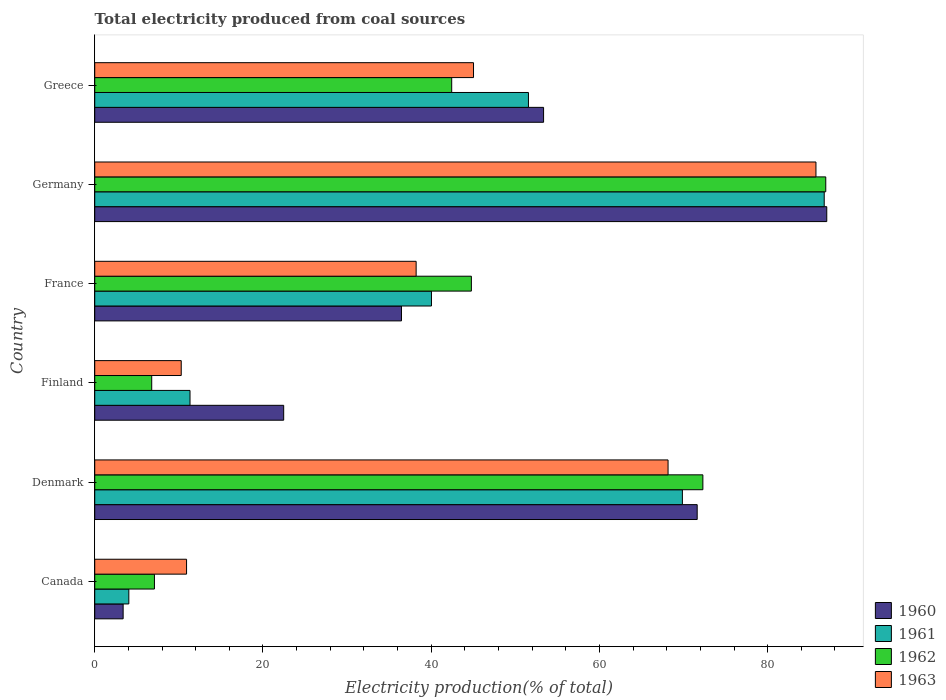How many groups of bars are there?
Provide a short and direct response. 6. Are the number of bars per tick equal to the number of legend labels?
Your response must be concise. Yes. Are the number of bars on each tick of the Y-axis equal?
Ensure brevity in your answer.  Yes. How many bars are there on the 2nd tick from the bottom?
Your response must be concise. 4. In how many cases, is the number of bars for a given country not equal to the number of legend labels?
Make the answer very short. 0. What is the total electricity produced in 1963 in Germany?
Give a very brief answer. 85.74. Across all countries, what is the maximum total electricity produced in 1962?
Ensure brevity in your answer.  86.91. Across all countries, what is the minimum total electricity produced in 1961?
Make the answer very short. 4.05. In which country was the total electricity produced in 1961 maximum?
Provide a short and direct response. Germany. In which country was the total electricity produced in 1960 minimum?
Provide a short and direct response. Canada. What is the total total electricity produced in 1962 in the graph?
Provide a succinct answer. 260.3. What is the difference between the total electricity produced in 1962 in France and that in Greece?
Provide a succinct answer. 2.34. What is the difference between the total electricity produced in 1963 in Greece and the total electricity produced in 1961 in France?
Keep it short and to the point. 5. What is the average total electricity produced in 1963 per country?
Keep it short and to the point. 43.06. What is the difference between the total electricity produced in 1962 and total electricity produced in 1963 in France?
Offer a terse response. 6.57. In how many countries, is the total electricity produced in 1963 greater than 44 %?
Make the answer very short. 3. What is the ratio of the total electricity produced in 1963 in Germany to that in Greece?
Provide a short and direct response. 1.9. What is the difference between the highest and the second highest total electricity produced in 1962?
Keep it short and to the point. 14.61. What is the difference between the highest and the lowest total electricity produced in 1962?
Keep it short and to the point. 80.13. Is it the case that in every country, the sum of the total electricity produced in 1963 and total electricity produced in 1962 is greater than the sum of total electricity produced in 1961 and total electricity produced in 1960?
Give a very brief answer. No. Is it the case that in every country, the sum of the total electricity produced in 1961 and total electricity produced in 1963 is greater than the total electricity produced in 1960?
Offer a terse response. No. How many bars are there?
Your answer should be very brief. 24. What is the difference between two consecutive major ticks on the X-axis?
Offer a very short reply. 20. Does the graph contain any zero values?
Your answer should be compact. No. Does the graph contain grids?
Your response must be concise. No. Where does the legend appear in the graph?
Your answer should be compact. Bottom right. How many legend labels are there?
Your answer should be very brief. 4. What is the title of the graph?
Your answer should be very brief. Total electricity produced from coal sources. Does "1982" appear as one of the legend labels in the graph?
Give a very brief answer. No. What is the label or title of the X-axis?
Ensure brevity in your answer.  Electricity production(% of total). What is the Electricity production(% of total) of 1960 in Canada?
Provide a succinct answer. 3.38. What is the Electricity production(% of total) of 1961 in Canada?
Your answer should be very brief. 4.05. What is the Electricity production(% of total) of 1962 in Canada?
Your answer should be compact. 7.1. What is the Electricity production(% of total) of 1963 in Canada?
Ensure brevity in your answer.  10.92. What is the Electricity production(% of total) in 1960 in Denmark?
Provide a short and direct response. 71.62. What is the Electricity production(% of total) in 1961 in Denmark?
Ensure brevity in your answer.  69.86. What is the Electricity production(% of total) in 1962 in Denmark?
Offer a terse response. 72.3. What is the Electricity production(% of total) in 1963 in Denmark?
Ensure brevity in your answer.  68.16. What is the Electricity production(% of total) in 1960 in Finland?
Your response must be concise. 22.46. What is the Electricity production(% of total) in 1961 in Finland?
Give a very brief answer. 11.33. What is the Electricity production(% of total) of 1962 in Finland?
Your answer should be compact. 6.78. What is the Electricity production(% of total) of 1963 in Finland?
Provide a succinct answer. 10.28. What is the Electricity production(% of total) of 1960 in France?
Make the answer very short. 36.47. What is the Electricity production(% of total) of 1961 in France?
Keep it short and to the point. 40.03. What is the Electricity production(% of total) in 1962 in France?
Provide a short and direct response. 44.78. What is the Electricity production(% of total) of 1963 in France?
Provide a short and direct response. 38.21. What is the Electricity production(% of total) in 1960 in Germany?
Your answer should be very brief. 87.03. What is the Electricity production(% of total) of 1961 in Germany?
Keep it short and to the point. 86.73. What is the Electricity production(% of total) in 1962 in Germany?
Your answer should be very brief. 86.91. What is the Electricity production(% of total) of 1963 in Germany?
Provide a succinct answer. 85.74. What is the Electricity production(% of total) in 1960 in Greece?
Keep it short and to the point. 53.36. What is the Electricity production(% of total) of 1961 in Greece?
Offer a terse response. 51.56. What is the Electricity production(% of total) of 1962 in Greece?
Your response must be concise. 42.44. What is the Electricity production(% of total) of 1963 in Greece?
Give a very brief answer. 45.03. Across all countries, what is the maximum Electricity production(% of total) in 1960?
Your answer should be compact. 87.03. Across all countries, what is the maximum Electricity production(% of total) of 1961?
Your answer should be very brief. 86.73. Across all countries, what is the maximum Electricity production(% of total) in 1962?
Ensure brevity in your answer.  86.91. Across all countries, what is the maximum Electricity production(% of total) in 1963?
Your answer should be very brief. 85.74. Across all countries, what is the minimum Electricity production(% of total) of 1960?
Keep it short and to the point. 3.38. Across all countries, what is the minimum Electricity production(% of total) in 1961?
Provide a succinct answer. 4.05. Across all countries, what is the minimum Electricity production(% of total) in 1962?
Give a very brief answer. 6.78. Across all countries, what is the minimum Electricity production(% of total) in 1963?
Give a very brief answer. 10.28. What is the total Electricity production(% of total) in 1960 in the graph?
Make the answer very short. 274.33. What is the total Electricity production(% of total) of 1961 in the graph?
Your answer should be very brief. 263.57. What is the total Electricity production(% of total) of 1962 in the graph?
Ensure brevity in your answer.  260.3. What is the total Electricity production(% of total) of 1963 in the graph?
Give a very brief answer. 258.35. What is the difference between the Electricity production(% of total) of 1960 in Canada and that in Denmark?
Offer a very short reply. -68.25. What is the difference between the Electricity production(% of total) of 1961 in Canada and that in Denmark?
Your answer should be compact. -65.81. What is the difference between the Electricity production(% of total) of 1962 in Canada and that in Denmark?
Keep it short and to the point. -65.2. What is the difference between the Electricity production(% of total) in 1963 in Canada and that in Denmark?
Provide a succinct answer. -57.24. What is the difference between the Electricity production(% of total) in 1960 in Canada and that in Finland?
Offer a terse response. -19.09. What is the difference between the Electricity production(% of total) of 1961 in Canada and that in Finland?
Keep it short and to the point. -7.27. What is the difference between the Electricity production(% of total) of 1962 in Canada and that in Finland?
Your answer should be compact. 0.32. What is the difference between the Electricity production(% of total) of 1963 in Canada and that in Finland?
Your answer should be very brief. 0.63. What is the difference between the Electricity production(% of total) in 1960 in Canada and that in France?
Provide a succinct answer. -33.09. What is the difference between the Electricity production(% of total) in 1961 in Canada and that in France?
Offer a very short reply. -35.98. What is the difference between the Electricity production(% of total) of 1962 in Canada and that in France?
Give a very brief answer. -37.68. What is the difference between the Electricity production(% of total) of 1963 in Canada and that in France?
Make the answer very short. -27.29. What is the difference between the Electricity production(% of total) of 1960 in Canada and that in Germany?
Provide a succinct answer. -83.65. What is the difference between the Electricity production(% of total) of 1961 in Canada and that in Germany?
Your answer should be very brief. -82.67. What is the difference between the Electricity production(% of total) of 1962 in Canada and that in Germany?
Your answer should be compact. -79.81. What is the difference between the Electricity production(% of total) in 1963 in Canada and that in Germany?
Make the answer very short. -74.83. What is the difference between the Electricity production(% of total) of 1960 in Canada and that in Greece?
Ensure brevity in your answer.  -49.98. What is the difference between the Electricity production(% of total) in 1961 in Canada and that in Greece?
Provide a short and direct response. -47.51. What is the difference between the Electricity production(% of total) of 1962 in Canada and that in Greece?
Keep it short and to the point. -35.34. What is the difference between the Electricity production(% of total) in 1963 in Canada and that in Greece?
Ensure brevity in your answer.  -34.11. What is the difference between the Electricity production(% of total) in 1960 in Denmark and that in Finland?
Offer a very short reply. 49.16. What is the difference between the Electricity production(% of total) of 1961 in Denmark and that in Finland?
Provide a short and direct response. 58.54. What is the difference between the Electricity production(% of total) in 1962 in Denmark and that in Finland?
Provide a succinct answer. 65.53. What is the difference between the Electricity production(% of total) of 1963 in Denmark and that in Finland?
Ensure brevity in your answer.  57.88. What is the difference between the Electricity production(% of total) of 1960 in Denmark and that in France?
Your answer should be compact. 35.16. What is the difference between the Electricity production(% of total) in 1961 in Denmark and that in France?
Your answer should be very brief. 29.83. What is the difference between the Electricity production(% of total) of 1962 in Denmark and that in France?
Your answer should be compact. 27.52. What is the difference between the Electricity production(% of total) of 1963 in Denmark and that in France?
Provide a succinct answer. 29.95. What is the difference between the Electricity production(% of total) of 1960 in Denmark and that in Germany?
Provide a succinct answer. -15.4. What is the difference between the Electricity production(% of total) in 1961 in Denmark and that in Germany?
Offer a terse response. -16.86. What is the difference between the Electricity production(% of total) of 1962 in Denmark and that in Germany?
Offer a very short reply. -14.61. What is the difference between the Electricity production(% of total) of 1963 in Denmark and that in Germany?
Your answer should be very brief. -17.58. What is the difference between the Electricity production(% of total) in 1960 in Denmark and that in Greece?
Ensure brevity in your answer.  18.26. What is the difference between the Electricity production(% of total) of 1961 in Denmark and that in Greece?
Your response must be concise. 18.3. What is the difference between the Electricity production(% of total) of 1962 in Denmark and that in Greece?
Provide a succinct answer. 29.86. What is the difference between the Electricity production(% of total) in 1963 in Denmark and that in Greece?
Provide a short and direct response. 23.13. What is the difference between the Electricity production(% of total) of 1960 in Finland and that in France?
Your answer should be very brief. -14.01. What is the difference between the Electricity production(% of total) of 1961 in Finland and that in France?
Your answer should be compact. -28.71. What is the difference between the Electricity production(% of total) in 1962 in Finland and that in France?
Keep it short and to the point. -38. What is the difference between the Electricity production(% of total) in 1963 in Finland and that in France?
Your answer should be compact. -27.93. What is the difference between the Electricity production(% of total) of 1960 in Finland and that in Germany?
Keep it short and to the point. -64.57. What is the difference between the Electricity production(% of total) of 1961 in Finland and that in Germany?
Your response must be concise. -75.4. What is the difference between the Electricity production(% of total) of 1962 in Finland and that in Germany?
Your answer should be compact. -80.13. What is the difference between the Electricity production(% of total) in 1963 in Finland and that in Germany?
Give a very brief answer. -75.46. What is the difference between the Electricity production(% of total) of 1960 in Finland and that in Greece?
Provide a short and direct response. -30.9. What is the difference between the Electricity production(% of total) in 1961 in Finland and that in Greece?
Ensure brevity in your answer.  -40.24. What is the difference between the Electricity production(% of total) in 1962 in Finland and that in Greece?
Provide a short and direct response. -35.66. What is the difference between the Electricity production(% of total) of 1963 in Finland and that in Greece?
Provide a succinct answer. -34.75. What is the difference between the Electricity production(% of total) in 1960 in France and that in Germany?
Provide a short and direct response. -50.56. What is the difference between the Electricity production(% of total) in 1961 in France and that in Germany?
Offer a terse response. -46.69. What is the difference between the Electricity production(% of total) of 1962 in France and that in Germany?
Keep it short and to the point. -42.13. What is the difference between the Electricity production(% of total) in 1963 in France and that in Germany?
Keep it short and to the point. -47.53. What is the difference between the Electricity production(% of total) of 1960 in France and that in Greece?
Your response must be concise. -16.89. What is the difference between the Electricity production(% of total) in 1961 in France and that in Greece?
Offer a terse response. -11.53. What is the difference between the Electricity production(% of total) of 1962 in France and that in Greece?
Make the answer very short. 2.34. What is the difference between the Electricity production(% of total) of 1963 in France and that in Greece?
Your response must be concise. -6.82. What is the difference between the Electricity production(% of total) in 1960 in Germany and that in Greece?
Keep it short and to the point. 33.67. What is the difference between the Electricity production(% of total) of 1961 in Germany and that in Greece?
Your response must be concise. 35.16. What is the difference between the Electricity production(% of total) of 1962 in Germany and that in Greece?
Provide a succinct answer. 44.47. What is the difference between the Electricity production(% of total) of 1963 in Germany and that in Greece?
Your response must be concise. 40.71. What is the difference between the Electricity production(% of total) of 1960 in Canada and the Electricity production(% of total) of 1961 in Denmark?
Offer a very short reply. -66.49. What is the difference between the Electricity production(% of total) in 1960 in Canada and the Electricity production(% of total) in 1962 in Denmark?
Your answer should be compact. -68.92. What is the difference between the Electricity production(% of total) of 1960 in Canada and the Electricity production(% of total) of 1963 in Denmark?
Keep it short and to the point. -64.78. What is the difference between the Electricity production(% of total) in 1961 in Canada and the Electricity production(% of total) in 1962 in Denmark?
Ensure brevity in your answer.  -68.25. What is the difference between the Electricity production(% of total) of 1961 in Canada and the Electricity production(% of total) of 1963 in Denmark?
Provide a succinct answer. -64.11. What is the difference between the Electricity production(% of total) in 1962 in Canada and the Electricity production(% of total) in 1963 in Denmark?
Ensure brevity in your answer.  -61.06. What is the difference between the Electricity production(% of total) in 1960 in Canada and the Electricity production(% of total) in 1961 in Finland?
Keep it short and to the point. -7.95. What is the difference between the Electricity production(% of total) of 1960 in Canada and the Electricity production(% of total) of 1962 in Finland?
Offer a terse response. -3.4. What is the difference between the Electricity production(% of total) in 1960 in Canada and the Electricity production(% of total) in 1963 in Finland?
Give a very brief answer. -6.91. What is the difference between the Electricity production(% of total) in 1961 in Canada and the Electricity production(% of total) in 1962 in Finland?
Keep it short and to the point. -2.72. What is the difference between the Electricity production(% of total) of 1961 in Canada and the Electricity production(% of total) of 1963 in Finland?
Give a very brief answer. -6.23. What is the difference between the Electricity production(% of total) in 1962 in Canada and the Electricity production(% of total) in 1963 in Finland?
Ensure brevity in your answer.  -3.18. What is the difference between the Electricity production(% of total) of 1960 in Canada and the Electricity production(% of total) of 1961 in France?
Provide a short and direct response. -36.66. What is the difference between the Electricity production(% of total) in 1960 in Canada and the Electricity production(% of total) in 1962 in France?
Offer a very short reply. -41.4. What is the difference between the Electricity production(% of total) in 1960 in Canada and the Electricity production(% of total) in 1963 in France?
Make the answer very short. -34.83. What is the difference between the Electricity production(% of total) of 1961 in Canada and the Electricity production(% of total) of 1962 in France?
Offer a very short reply. -40.72. What is the difference between the Electricity production(% of total) of 1961 in Canada and the Electricity production(% of total) of 1963 in France?
Ensure brevity in your answer.  -34.16. What is the difference between the Electricity production(% of total) in 1962 in Canada and the Electricity production(% of total) in 1963 in France?
Ensure brevity in your answer.  -31.11. What is the difference between the Electricity production(% of total) in 1960 in Canada and the Electricity production(% of total) in 1961 in Germany?
Provide a short and direct response. -83.35. What is the difference between the Electricity production(% of total) in 1960 in Canada and the Electricity production(% of total) in 1962 in Germany?
Your answer should be very brief. -83.53. What is the difference between the Electricity production(% of total) in 1960 in Canada and the Electricity production(% of total) in 1963 in Germany?
Your answer should be compact. -82.36. What is the difference between the Electricity production(% of total) in 1961 in Canada and the Electricity production(% of total) in 1962 in Germany?
Give a very brief answer. -82.86. What is the difference between the Electricity production(% of total) of 1961 in Canada and the Electricity production(% of total) of 1963 in Germany?
Your answer should be compact. -81.69. What is the difference between the Electricity production(% of total) in 1962 in Canada and the Electricity production(% of total) in 1963 in Germany?
Make the answer very short. -78.64. What is the difference between the Electricity production(% of total) in 1960 in Canada and the Electricity production(% of total) in 1961 in Greece?
Give a very brief answer. -48.19. What is the difference between the Electricity production(% of total) of 1960 in Canada and the Electricity production(% of total) of 1962 in Greece?
Keep it short and to the point. -39.06. What is the difference between the Electricity production(% of total) in 1960 in Canada and the Electricity production(% of total) in 1963 in Greece?
Offer a terse response. -41.65. What is the difference between the Electricity production(% of total) in 1961 in Canada and the Electricity production(% of total) in 1962 in Greece?
Give a very brief answer. -38.39. What is the difference between the Electricity production(% of total) of 1961 in Canada and the Electricity production(% of total) of 1963 in Greece?
Keep it short and to the point. -40.98. What is the difference between the Electricity production(% of total) in 1962 in Canada and the Electricity production(% of total) in 1963 in Greece?
Make the answer very short. -37.93. What is the difference between the Electricity production(% of total) of 1960 in Denmark and the Electricity production(% of total) of 1961 in Finland?
Provide a short and direct response. 60.3. What is the difference between the Electricity production(% of total) of 1960 in Denmark and the Electricity production(% of total) of 1962 in Finland?
Your answer should be compact. 64.85. What is the difference between the Electricity production(% of total) in 1960 in Denmark and the Electricity production(% of total) in 1963 in Finland?
Keep it short and to the point. 61.34. What is the difference between the Electricity production(% of total) in 1961 in Denmark and the Electricity production(% of total) in 1962 in Finland?
Provide a succinct answer. 63.09. What is the difference between the Electricity production(% of total) of 1961 in Denmark and the Electricity production(% of total) of 1963 in Finland?
Make the answer very short. 59.58. What is the difference between the Electricity production(% of total) of 1962 in Denmark and the Electricity production(% of total) of 1963 in Finland?
Your answer should be compact. 62.02. What is the difference between the Electricity production(% of total) of 1960 in Denmark and the Electricity production(% of total) of 1961 in France?
Keep it short and to the point. 31.59. What is the difference between the Electricity production(% of total) of 1960 in Denmark and the Electricity production(% of total) of 1962 in France?
Offer a very short reply. 26.85. What is the difference between the Electricity production(% of total) of 1960 in Denmark and the Electricity production(% of total) of 1963 in France?
Offer a terse response. 33.41. What is the difference between the Electricity production(% of total) of 1961 in Denmark and the Electricity production(% of total) of 1962 in France?
Your answer should be compact. 25.09. What is the difference between the Electricity production(% of total) in 1961 in Denmark and the Electricity production(% of total) in 1963 in France?
Your answer should be compact. 31.65. What is the difference between the Electricity production(% of total) in 1962 in Denmark and the Electricity production(% of total) in 1963 in France?
Provide a succinct answer. 34.09. What is the difference between the Electricity production(% of total) in 1960 in Denmark and the Electricity production(% of total) in 1961 in Germany?
Your response must be concise. -15.1. What is the difference between the Electricity production(% of total) of 1960 in Denmark and the Electricity production(% of total) of 1962 in Germany?
Keep it short and to the point. -15.28. What is the difference between the Electricity production(% of total) of 1960 in Denmark and the Electricity production(% of total) of 1963 in Germany?
Your answer should be compact. -14.12. What is the difference between the Electricity production(% of total) in 1961 in Denmark and the Electricity production(% of total) in 1962 in Germany?
Offer a very short reply. -17.04. What is the difference between the Electricity production(% of total) in 1961 in Denmark and the Electricity production(% of total) in 1963 in Germany?
Keep it short and to the point. -15.88. What is the difference between the Electricity production(% of total) in 1962 in Denmark and the Electricity production(% of total) in 1963 in Germany?
Ensure brevity in your answer.  -13.44. What is the difference between the Electricity production(% of total) of 1960 in Denmark and the Electricity production(% of total) of 1961 in Greece?
Offer a very short reply. 20.06. What is the difference between the Electricity production(% of total) in 1960 in Denmark and the Electricity production(% of total) in 1962 in Greece?
Provide a succinct answer. 29.18. What is the difference between the Electricity production(% of total) in 1960 in Denmark and the Electricity production(% of total) in 1963 in Greece?
Ensure brevity in your answer.  26.59. What is the difference between the Electricity production(% of total) in 1961 in Denmark and the Electricity production(% of total) in 1962 in Greece?
Ensure brevity in your answer.  27.42. What is the difference between the Electricity production(% of total) of 1961 in Denmark and the Electricity production(% of total) of 1963 in Greece?
Make the answer very short. 24.83. What is the difference between the Electricity production(% of total) of 1962 in Denmark and the Electricity production(% of total) of 1963 in Greece?
Your answer should be compact. 27.27. What is the difference between the Electricity production(% of total) in 1960 in Finland and the Electricity production(% of total) in 1961 in France?
Ensure brevity in your answer.  -17.57. What is the difference between the Electricity production(% of total) of 1960 in Finland and the Electricity production(% of total) of 1962 in France?
Provide a short and direct response. -22.31. What is the difference between the Electricity production(% of total) in 1960 in Finland and the Electricity production(% of total) in 1963 in France?
Provide a succinct answer. -15.75. What is the difference between the Electricity production(% of total) of 1961 in Finland and the Electricity production(% of total) of 1962 in France?
Offer a terse response. -33.45. What is the difference between the Electricity production(% of total) in 1961 in Finland and the Electricity production(% of total) in 1963 in France?
Offer a very short reply. -26.88. What is the difference between the Electricity production(% of total) of 1962 in Finland and the Electricity production(% of total) of 1963 in France?
Provide a succinct answer. -31.44. What is the difference between the Electricity production(% of total) in 1960 in Finland and the Electricity production(% of total) in 1961 in Germany?
Offer a very short reply. -64.26. What is the difference between the Electricity production(% of total) in 1960 in Finland and the Electricity production(% of total) in 1962 in Germany?
Your answer should be compact. -64.45. What is the difference between the Electricity production(% of total) in 1960 in Finland and the Electricity production(% of total) in 1963 in Germany?
Your answer should be very brief. -63.28. What is the difference between the Electricity production(% of total) of 1961 in Finland and the Electricity production(% of total) of 1962 in Germany?
Keep it short and to the point. -75.58. What is the difference between the Electricity production(% of total) of 1961 in Finland and the Electricity production(% of total) of 1963 in Germany?
Provide a short and direct response. -74.41. What is the difference between the Electricity production(% of total) in 1962 in Finland and the Electricity production(% of total) in 1963 in Germany?
Your response must be concise. -78.97. What is the difference between the Electricity production(% of total) in 1960 in Finland and the Electricity production(% of total) in 1961 in Greece?
Your response must be concise. -29.1. What is the difference between the Electricity production(% of total) in 1960 in Finland and the Electricity production(% of total) in 1962 in Greece?
Make the answer very short. -19.98. What is the difference between the Electricity production(% of total) of 1960 in Finland and the Electricity production(% of total) of 1963 in Greece?
Your answer should be compact. -22.57. What is the difference between the Electricity production(% of total) in 1961 in Finland and the Electricity production(% of total) in 1962 in Greece?
Offer a terse response. -31.11. What is the difference between the Electricity production(% of total) of 1961 in Finland and the Electricity production(% of total) of 1963 in Greece?
Make the answer very short. -33.7. What is the difference between the Electricity production(% of total) of 1962 in Finland and the Electricity production(% of total) of 1963 in Greece?
Keep it short and to the point. -38.26. What is the difference between the Electricity production(% of total) of 1960 in France and the Electricity production(% of total) of 1961 in Germany?
Your answer should be very brief. -50.26. What is the difference between the Electricity production(% of total) of 1960 in France and the Electricity production(% of total) of 1962 in Germany?
Provide a succinct answer. -50.44. What is the difference between the Electricity production(% of total) of 1960 in France and the Electricity production(% of total) of 1963 in Germany?
Keep it short and to the point. -49.27. What is the difference between the Electricity production(% of total) in 1961 in France and the Electricity production(% of total) in 1962 in Germany?
Ensure brevity in your answer.  -46.87. What is the difference between the Electricity production(% of total) of 1961 in France and the Electricity production(% of total) of 1963 in Germany?
Your response must be concise. -45.71. What is the difference between the Electricity production(% of total) of 1962 in France and the Electricity production(% of total) of 1963 in Germany?
Your answer should be compact. -40.97. What is the difference between the Electricity production(% of total) of 1960 in France and the Electricity production(% of total) of 1961 in Greece?
Provide a succinct answer. -15.09. What is the difference between the Electricity production(% of total) of 1960 in France and the Electricity production(% of total) of 1962 in Greece?
Offer a terse response. -5.97. What is the difference between the Electricity production(% of total) of 1960 in France and the Electricity production(% of total) of 1963 in Greece?
Give a very brief answer. -8.56. What is the difference between the Electricity production(% of total) of 1961 in France and the Electricity production(% of total) of 1962 in Greece?
Provide a succinct answer. -2.41. What is the difference between the Electricity production(% of total) in 1961 in France and the Electricity production(% of total) in 1963 in Greece?
Provide a short and direct response. -5. What is the difference between the Electricity production(% of total) in 1962 in France and the Electricity production(% of total) in 1963 in Greece?
Provide a succinct answer. -0.25. What is the difference between the Electricity production(% of total) in 1960 in Germany and the Electricity production(% of total) in 1961 in Greece?
Your response must be concise. 35.47. What is the difference between the Electricity production(% of total) of 1960 in Germany and the Electricity production(% of total) of 1962 in Greece?
Give a very brief answer. 44.59. What is the difference between the Electricity production(% of total) of 1960 in Germany and the Electricity production(% of total) of 1963 in Greece?
Offer a terse response. 42. What is the difference between the Electricity production(% of total) of 1961 in Germany and the Electricity production(% of total) of 1962 in Greece?
Provide a short and direct response. 44.29. What is the difference between the Electricity production(% of total) of 1961 in Germany and the Electricity production(% of total) of 1963 in Greece?
Your response must be concise. 41.69. What is the difference between the Electricity production(% of total) of 1962 in Germany and the Electricity production(% of total) of 1963 in Greece?
Offer a terse response. 41.88. What is the average Electricity production(% of total) in 1960 per country?
Offer a very short reply. 45.72. What is the average Electricity production(% of total) of 1961 per country?
Your response must be concise. 43.93. What is the average Electricity production(% of total) in 1962 per country?
Offer a terse response. 43.38. What is the average Electricity production(% of total) of 1963 per country?
Offer a terse response. 43.06. What is the difference between the Electricity production(% of total) in 1960 and Electricity production(% of total) in 1961 in Canada?
Provide a succinct answer. -0.68. What is the difference between the Electricity production(% of total) in 1960 and Electricity production(% of total) in 1962 in Canada?
Keep it short and to the point. -3.72. What is the difference between the Electricity production(% of total) of 1960 and Electricity production(% of total) of 1963 in Canada?
Offer a very short reply. -7.54. What is the difference between the Electricity production(% of total) in 1961 and Electricity production(% of total) in 1962 in Canada?
Keep it short and to the point. -3.04. What is the difference between the Electricity production(% of total) in 1961 and Electricity production(% of total) in 1963 in Canada?
Provide a short and direct response. -6.86. What is the difference between the Electricity production(% of total) in 1962 and Electricity production(% of total) in 1963 in Canada?
Your response must be concise. -3.82. What is the difference between the Electricity production(% of total) of 1960 and Electricity production(% of total) of 1961 in Denmark?
Your answer should be compact. 1.76. What is the difference between the Electricity production(% of total) of 1960 and Electricity production(% of total) of 1962 in Denmark?
Keep it short and to the point. -0.68. What is the difference between the Electricity production(% of total) in 1960 and Electricity production(% of total) in 1963 in Denmark?
Your answer should be very brief. 3.46. What is the difference between the Electricity production(% of total) in 1961 and Electricity production(% of total) in 1962 in Denmark?
Ensure brevity in your answer.  -2.44. What is the difference between the Electricity production(% of total) in 1961 and Electricity production(% of total) in 1963 in Denmark?
Your answer should be compact. 1.7. What is the difference between the Electricity production(% of total) of 1962 and Electricity production(% of total) of 1963 in Denmark?
Make the answer very short. 4.14. What is the difference between the Electricity production(% of total) in 1960 and Electricity production(% of total) in 1961 in Finland?
Provide a short and direct response. 11.14. What is the difference between the Electricity production(% of total) of 1960 and Electricity production(% of total) of 1962 in Finland?
Keep it short and to the point. 15.69. What is the difference between the Electricity production(% of total) of 1960 and Electricity production(% of total) of 1963 in Finland?
Your answer should be compact. 12.18. What is the difference between the Electricity production(% of total) in 1961 and Electricity production(% of total) in 1962 in Finland?
Offer a very short reply. 4.55. What is the difference between the Electricity production(% of total) of 1961 and Electricity production(% of total) of 1963 in Finland?
Your response must be concise. 1.04. What is the difference between the Electricity production(% of total) of 1962 and Electricity production(% of total) of 1963 in Finland?
Provide a short and direct response. -3.51. What is the difference between the Electricity production(% of total) in 1960 and Electricity production(% of total) in 1961 in France?
Provide a short and direct response. -3.57. What is the difference between the Electricity production(% of total) of 1960 and Electricity production(% of total) of 1962 in France?
Your answer should be very brief. -8.31. What is the difference between the Electricity production(% of total) in 1960 and Electricity production(% of total) in 1963 in France?
Keep it short and to the point. -1.74. What is the difference between the Electricity production(% of total) of 1961 and Electricity production(% of total) of 1962 in France?
Provide a succinct answer. -4.74. What is the difference between the Electricity production(% of total) of 1961 and Electricity production(% of total) of 1963 in France?
Ensure brevity in your answer.  1.82. What is the difference between the Electricity production(% of total) in 1962 and Electricity production(% of total) in 1963 in France?
Ensure brevity in your answer.  6.57. What is the difference between the Electricity production(% of total) of 1960 and Electricity production(% of total) of 1961 in Germany?
Keep it short and to the point. 0.3. What is the difference between the Electricity production(% of total) in 1960 and Electricity production(% of total) in 1962 in Germany?
Offer a terse response. 0.12. What is the difference between the Electricity production(% of total) of 1960 and Electricity production(% of total) of 1963 in Germany?
Your answer should be very brief. 1.29. What is the difference between the Electricity production(% of total) in 1961 and Electricity production(% of total) in 1962 in Germany?
Provide a succinct answer. -0.18. What is the difference between the Electricity production(% of total) in 1961 and Electricity production(% of total) in 1963 in Germany?
Provide a short and direct response. 0.98. What is the difference between the Electricity production(% of total) of 1962 and Electricity production(% of total) of 1963 in Germany?
Ensure brevity in your answer.  1.17. What is the difference between the Electricity production(% of total) of 1960 and Electricity production(% of total) of 1961 in Greece?
Your answer should be compact. 1.8. What is the difference between the Electricity production(% of total) of 1960 and Electricity production(% of total) of 1962 in Greece?
Your response must be concise. 10.92. What is the difference between the Electricity production(% of total) of 1960 and Electricity production(% of total) of 1963 in Greece?
Keep it short and to the point. 8.33. What is the difference between the Electricity production(% of total) in 1961 and Electricity production(% of total) in 1962 in Greece?
Make the answer very short. 9.12. What is the difference between the Electricity production(% of total) of 1961 and Electricity production(% of total) of 1963 in Greece?
Offer a terse response. 6.53. What is the difference between the Electricity production(% of total) in 1962 and Electricity production(% of total) in 1963 in Greece?
Provide a succinct answer. -2.59. What is the ratio of the Electricity production(% of total) in 1960 in Canada to that in Denmark?
Keep it short and to the point. 0.05. What is the ratio of the Electricity production(% of total) of 1961 in Canada to that in Denmark?
Your response must be concise. 0.06. What is the ratio of the Electricity production(% of total) in 1962 in Canada to that in Denmark?
Give a very brief answer. 0.1. What is the ratio of the Electricity production(% of total) in 1963 in Canada to that in Denmark?
Your answer should be very brief. 0.16. What is the ratio of the Electricity production(% of total) of 1960 in Canada to that in Finland?
Your response must be concise. 0.15. What is the ratio of the Electricity production(% of total) in 1961 in Canada to that in Finland?
Offer a terse response. 0.36. What is the ratio of the Electricity production(% of total) of 1962 in Canada to that in Finland?
Ensure brevity in your answer.  1.05. What is the ratio of the Electricity production(% of total) in 1963 in Canada to that in Finland?
Offer a very short reply. 1.06. What is the ratio of the Electricity production(% of total) in 1960 in Canada to that in France?
Your answer should be compact. 0.09. What is the ratio of the Electricity production(% of total) of 1961 in Canada to that in France?
Provide a succinct answer. 0.1. What is the ratio of the Electricity production(% of total) in 1962 in Canada to that in France?
Your answer should be very brief. 0.16. What is the ratio of the Electricity production(% of total) in 1963 in Canada to that in France?
Keep it short and to the point. 0.29. What is the ratio of the Electricity production(% of total) in 1960 in Canada to that in Germany?
Offer a terse response. 0.04. What is the ratio of the Electricity production(% of total) in 1961 in Canada to that in Germany?
Offer a terse response. 0.05. What is the ratio of the Electricity production(% of total) of 1962 in Canada to that in Germany?
Your answer should be compact. 0.08. What is the ratio of the Electricity production(% of total) of 1963 in Canada to that in Germany?
Offer a terse response. 0.13. What is the ratio of the Electricity production(% of total) in 1960 in Canada to that in Greece?
Make the answer very short. 0.06. What is the ratio of the Electricity production(% of total) in 1961 in Canada to that in Greece?
Provide a succinct answer. 0.08. What is the ratio of the Electricity production(% of total) of 1962 in Canada to that in Greece?
Provide a short and direct response. 0.17. What is the ratio of the Electricity production(% of total) in 1963 in Canada to that in Greece?
Your answer should be very brief. 0.24. What is the ratio of the Electricity production(% of total) in 1960 in Denmark to that in Finland?
Provide a succinct answer. 3.19. What is the ratio of the Electricity production(% of total) in 1961 in Denmark to that in Finland?
Make the answer very short. 6.17. What is the ratio of the Electricity production(% of total) in 1962 in Denmark to that in Finland?
Give a very brief answer. 10.67. What is the ratio of the Electricity production(% of total) of 1963 in Denmark to that in Finland?
Make the answer very short. 6.63. What is the ratio of the Electricity production(% of total) of 1960 in Denmark to that in France?
Offer a terse response. 1.96. What is the ratio of the Electricity production(% of total) in 1961 in Denmark to that in France?
Make the answer very short. 1.75. What is the ratio of the Electricity production(% of total) of 1962 in Denmark to that in France?
Ensure brevity in your answer.  1.61. What is the ratio of the Electricity production(% of total) in 1963 in Denmark to that in France?
Keep it short and to the point. 1.78. What is the ratio of the Electricity production(% of total) in 1960 in Denmark to that in Germany?
Give a very brief answer. 0.82. What is the ratio of the Electricity production(% of total) of 1961 in Denmark to that in Germany?
Your answer should be very brief. 0.81. What is the ratio of the Electricity production(% of total) of 1962 in Denmark to that in Germany?
Ensure brevity in your answer.  0.83. What is the ratio of the Electricity production(% of total) of 1963 in Denmark to that in Germany?
Your answer should be compact. 0.79. What is the ratio of the Electricity production(% of total) in 1960 in Denmark to that in Greece?
Make the answer very short. 1.34. What is the ratio of the Electricity production(% of total) in 1961 in Denmark to that in Greece?
Make the answer very short. 1.35. What is the ratio of the Electricity production(% of total) of 1962 in Denmark to that in Greece?
Offer a terse response. 1.7. What is the ratio of the Electricity production(% of total) of 1963 in Denmark to that in Greece?
Your answer should be very brief. 1.51. What is the ratio of the Electricity production(% of total) of 1960 in Finland to that in France?
Provide a short and direct response. 0.62. What is the ratio of the Electricity production(% of total) in 1961 in Finland to that in France?
Offer a terse response. 0.28. What is the ratio of the Electricity production(% of total) of 1962 in Finland to that in France?
Provide a succinct answer. 0.15. What is the ratio of the Electricity production(% of total) of 1963 in Finland to that in France?
Make the answer very short. 0.27. What is the ratio of the Electricity production(% of total) of 1960 in Finland to that in Germany?
Give a very brief answer. 0.26. What is the ratio of the Electricity production(% of total) of 1961 in Finland to that in Germany?
Offer a terse response. 0.13. What is the ratio of the Electricity production(% of total) of 1962 in Finland to that in Germany?
Your answer should be very brief. 0.08. What is the ratio of the Electricity production(% of total) of 1963 in Finland to that in Germany?
Your answer should be very brief. 0.12. What is the ratio of the Electricity production(% of total) of 1960 in Finland to that in Greece?
Keep it short and to the point. 0.42. What is the ratio of the Electricity production(% of total) of 1961 in Finland to that in Greece?
Your answer should be compact. 0.22. What is the ratio of the Electricity production(% of total) of 1962 in Finland to that in Greece?
Make the answer very short. 0.16. What is the ratio of the Electricity production(% of total) of 1963 in Finland to that in Greece?
Provide a succinct answer. 0.23. What is the ratio of the Electricity production(% of total) of 1960 in France to that in Germany?
Give a very brief answer. 0.42. What is the ratio of the Electricity production(% of total) of 1961 in France to that in Germany?
Offer a very short reply. 0.46. What is the ratio of the Electricity production(% of total) of 1962 in France to that in Germany?
Give a very brief answer. 0.52. What is the ratio of the Electricity production(% of total) in 1963 in France to that in Germany?
Keep it short and to the point. 0.45. What is the ratio of the Electricity production(% of total) in 1960 in France to that in Greece?
Your answer should be compact. 0.68. What is the ratio of the Electricity production(% of total) of 1961 in France to that in Greece?
Keep it short and to the point. 0.78. What is the ratio of the Electricity production(% of total) of 1962 in France to that in Greece?
Your answer should be very brief. 1.06. What is the ratio of the Electricity production(% of total) of 1963 in France to that in Greece?
Provide a succinct answer. 0.85. What is the ratio of the Electricity production(% of total) in 1960 in Germany to that in Greece?
Give a very brief answer. 1.63. What is the ratio of the Electricity production(% of total) in 1961 in Germany to that in Greece?
Ensure brevity in your answer.  1.68. What is the ratio of the Electricity production(% of total) in 1962 in Germany to that in Greece?
Provide a succinct answer. 2.05. What is the ratio of the Electricity production(% of total) of 1963 in Germany to that in Greece?
Ensure brevity in your answer.  1.9. What is the difference between the highest and the second highest Electricity production(% of total) in 1960?
Your answer should be compact. 15.4. What is the difference between the highest and the second highest Electricity production(% of total) in 1961?
Keep it short and to the point. 16.86. What is the difference between the highest and the second highest Electricity production(% of total) in 1962?
Offer a terse response. 14.61. What is the difference between the highest and the second highest Electricity production(% of total) of 1963?
Your answer should be very brief. 17.58. What is the difference between the highest and the lowest Electricity production(% of total) of 1960?
Provide a succinct answer. 83.65. What is the difference between the highest and the lowest Electricity production(% of total) in 1961?
Offer a very short reply. 82.67. What is the difference between the highest and the lowest Electricity production(% of total) in 1962?
Make the answer very short. 80.13. What is the difference between the highest and the lowest Electricity production(% of total) of 1963?
Provide a short and direct response. 75.46. 